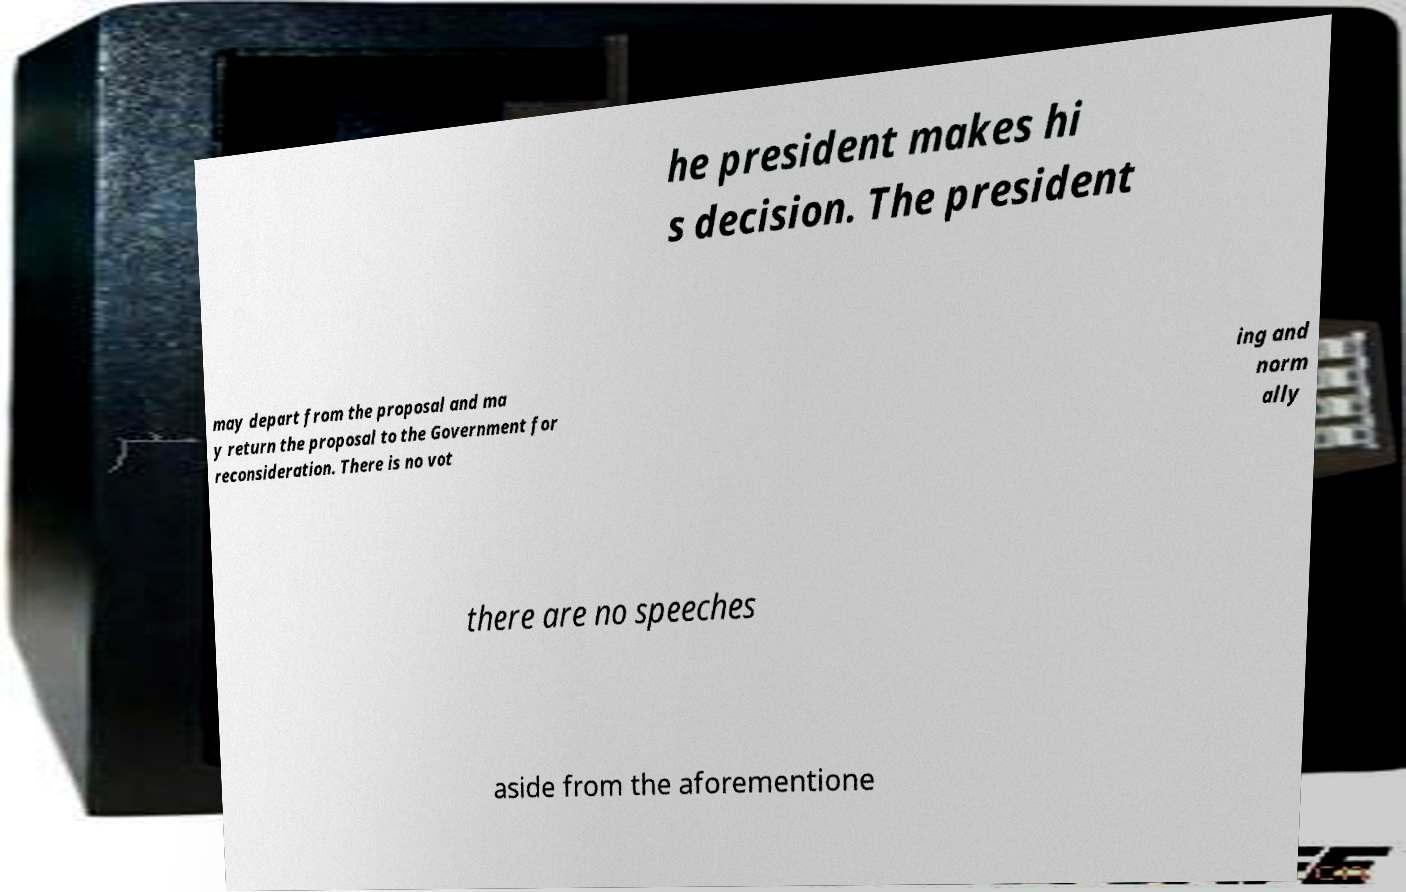There's text embedded in this image that I need extracted. Can you transcribe it verbatim? he president makes hi s decision. The president may depart from the proposal and ma y return the proposal to the Government for reconsideration. There is no vot ing and norm ally there are no speeches aside from the aforementione 